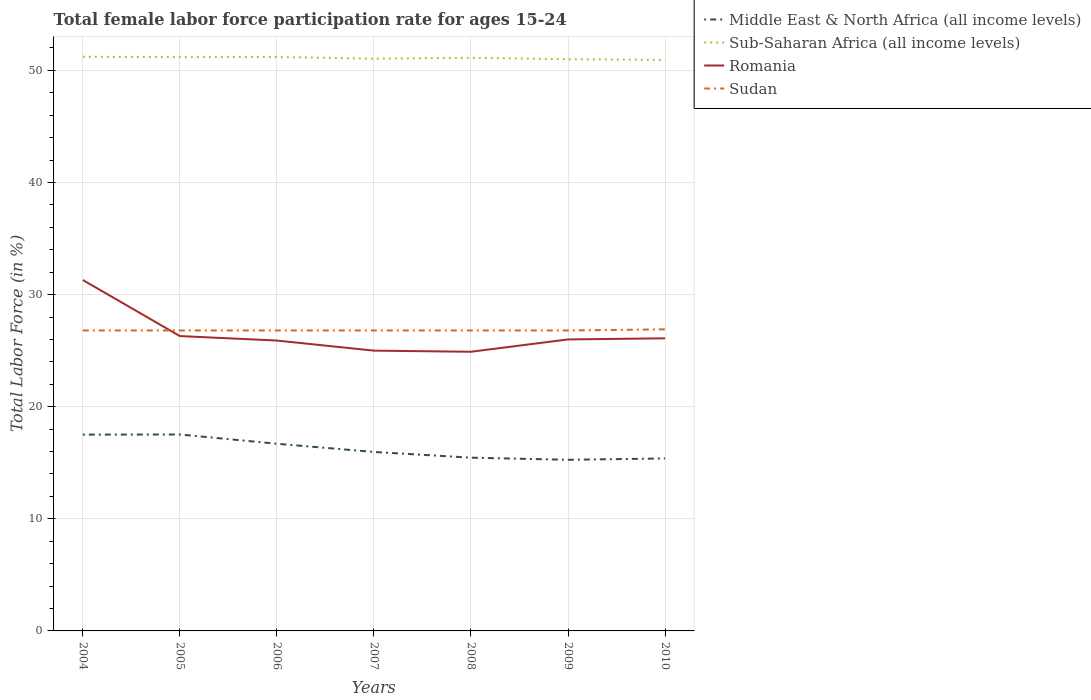Does the line corresponding to Sub-Saharan Africa (all income levels) intersect with the line corresponding to Middle East & North Africa (all income levels)?
Give a very brief answer. No. Is the number of lines equal to the number of legend labels?
Make the answer very short. Yes. Across all years, what is the maximum female labor force participation rate in Sub-Saharan Africa (all income levels)?
Give a very brief answer. 50.93. In which year was the female labor force participation rate in Sudan maximum?
Your response must be concise. 2004. What is the total female labor force participation rate in Romania in the graph?
Your answer should be very brief. 6.4. What is the difference between the highest and the second highest female labor force participation rate in Middle East & North Africa (all income levels)?
Your answer should be very brief. 2.26. How many lines are there?
Provide a short and direct response. 4. How many years are there in the graph?
Offer a terse response. 7. Does the graph contain grids?
Offer a terse response. Yes. Where does the legend appear in the graph?
Give a very brief answer. Top right. How many legend labels are there?
Provide a short and direct response. 4. What is the title of the graph?
Provide a short and direct response. Total female labor force participation rate for ages 15-24. Does "Chad" appear as one of the legend labels in the graph?
Make the answer very short. No. What is the Total Labor Force (in %) in Middle East & North Africa (all income levels) in 2004?
Your answer should be compact. 17.51. What is the Total Labor Force (in %) in Sub-Saharan Africa (all income levels) in 2004?
Your response must be concise. 51.22. What is the Total Labor Force (in %) of Romania in 2004?
Ensure brevity in your answer.  31.3. What is the Total Labor Force (in %) in Sudan in 2004?
Ensure brevity in your answer.  26.8. What is the Total Labor Force (in %) in Middle East & North Africa (all income levels) in 2005?
Provide a succinct answer. 17.52. What is the Total Labor Force (in %) in Sub-Saharan Africa (all income levels) in 2005?
Offer a very short reply. 51.18. What is the Total Labor Force (in %) in Romania in 2005?
Your answer should be compact. 26.3. What is the Total Labor Force (in %) in Sudan in 2005?
Your response must be concise. 26.8. What is the Total Labor Force (in %) in Middle East & North Africa (all income levels) in 2006?
Provide a succinct answer. 16.69. What is the Total Labor Force (in %) in Sub-Saharan Africa (all income levels) in 2006?
Provide a short and direct response. 51.19. What is the Total Labor Force (in %) in Romania in 2006?
Provide a succinct answer. 25.9. What is the Total Labor Force (in %) in Sudan in 2006?
Offer a terse response. 26.8. What is the Total Labor Force (in %) in Middle East & North Africa (all income levels) in 2007?
Your response must be concise. 15.96. What is the Total Labor Force (in %) of Sub-Saharan Africa (all income levels) in 2007?
Your answer should be compact. 51.04. What is the Total Labor Force (in %) in Romania in 2007?
Ensure brevity in your answer.  25. What is the Total Labor Force (in %) of Sudan in 2007?
Ensure brevity in your answer.  26.8. What is the Total Labor Force (in %) in Middle East & North Africa (all income levels) in 2008?
Your answer should be very brief. 15.45. What is the Total Labor Force (in %) in Sub-Saharan Africa (all income levels) in 2008?
Make the answer very short. 51.12. What is the Total Labor Force (in %) in Romania in 2008?
Provide a short and direct response. 24.9. What is the Total Labor Force (in %) of Sudan in 2008?
Your response must be concise. 26.8. What is the Total Labor Force (in %) of Middle East & North Africa (all income levels) in 2009?
Your response must be concise. 15.26. What is the Total Labor Force (in %) of Sub-Saharan Africa (all income levels) in 2009?
Give a very brief answer. 50.99. What is the Total Labor Force (in %) of Sudan in 2009?
Your response must be concise. 26.8. What is the Total Labor Force (in %) in Middle East & North Africa (all income levels) in 2010?
Give a very brief answer. 15.38. What is the Total Labor Force (in %) in Sub-Saharan Africa (all income levels) in 2010?
Provide a short and direct response. 50.93. What is the Total Labor Force (in %) in Romania in 2010?
Provide a short and direct response. 26.1. What is the Total Labor Force (in %) in Sudan in 2010?
Your answer should be compact. 26.9. Across all years, what is the maximum Total Labor Force (in %) in Middle East & North Africa (all income levels)?
Give a very brief answer. 17.52. Across all years, what is the maximum Total Labor Force (in %) of Sub-Saharan Africa (all income levels)?
Your response must be concise. 51.22. Across all years, what is the maximum Total Labor Force (in %) in Romania?
Your answer should be compact. 31.3. Across all years, what is the maximum Total Labor Force (in %) in Sudan?
Ensure brevity in your answer.  26.9. Across all years, what is the minimum Total Labor Force (in %) of Middle East & North Africa (all income levels)?
Give a very brief answer. 15.26. Across all years, what is the minimum Total Labor Force (in %) of Sub-Saharan Africa (all income levels)?
Keep it short and to the point. 50.93. Across all years, what is the minimum Total Labor Force (in %) in Romania?
Provide a succinct answer. 24.9. Across all years, what is the minimum Total Labor Force (in %) in Sudan?
Your response must be concise. 26.8. What is the total Total Labor Force (in %) of Middle East & North Africa (all income levels) in the graph?
Provide a succinct answer. 113.79. What is the total Total Labor Force (in %) in Sub-Saharan Africa (all income levels) in the graph?
Provide a succinct answer. 357.68. What is the total Total Labor Force (in %) of Romania in the graph?
Ensure brevity in your answer.  185.5. What is the total Total Labor Force (in %) in Sudan in the graph?
Ensure brevity in your answer.  187.7. What is the difference between the Total Labor Force (in %) of Middle East & North Africa (all income levels) in 2004 and that in 2005?
Your answer should be compact. -0.01. What is the difference between the Total Labor Force (in %) in Sub-Saharan Africa (all income levels) in 2004 and that in 2005?
Ensure brevity in your answer.  0.04. What is the difference between the Total Labor Force (in %) of Middle East & North Africa (all income levels) in 2004 and that in 2006?
Keep it short and to the point. 0.81. What is the difference between the Total Labor Force (in %) of Sub-Saharan Africa (all income levels) in 2004 and that in 2006?
Your answer should be compact. 0.02. What is the difference between the Total Labor Force (in %) of Sudan in 2004 and that in 2006?
Offer a very short reply. 0. What is the difference between the Total Labor Force (in %) of Middle East & North Africa (all income levels) in 2004 and that in 2007?
Offer a very short reply. 1.55. What is the difference between the Total Labor Force (in %) in Sub-Saharan Africa (all income levels) in 2004 and that in 2007?
Make the answer very short. 0.17. What is the difference between the Total Labor Force (in %) in Romania in 2004 and that in 2007?
Provide a succinct answer. 6.3. What is the difference between the Total Labor Force (in %) in Sudan in 2004 and that in 2007?
Give a very brief answer. 0. What is the difference between the Total Labor Force (in %) of Middle East & North Africa (all income levels) in 2004 and that in 2008?
Provide a short and direct response. 2.06. What is the difference between the Total Labor Force (in %) in Sub-Saharan Africa (all income levels) in 2004 and that in 2008?
Your answer should be compact. 0.1. What is the difference between the Total Labor Force (in %) of Sudan in 2004 and that in 2008?
Provide a succinct answer. 0. What is the difference between the Total Labor Force (in %) of Middle East & North Africa (all income levels) in 2004 and that in 2009?
Make the answer very short. 2.25. What is the difference between the Total Labor Force (in %) of Sub-Saharan Africa (all income levels) in 2004 and that in 2009?
Provide a succinct answer. 0.22. What is the difference between the Total Labor Force (in %) of Middle East & North Africa (all income levels) in 2004 and that in 2010?
Your answer should be compact. 2.13. What is the difference between the Total Labor Force (in %) in Sub-Saharan Africa (all income levels) in 2004 and that in 2010?
Keep it short and to the point. 0.28. What is the difference between the Total Labor Force (in %) in Romania in 2004 and that in 2010?
Give a very brief answer. 5.2. What is the difference between the Total Labor Force (in %) in Sudan in 2004 and that in 2010?
Offer a terse response. -0.1. What is the difference between the Total Labor Force (in %) of Middle East & North Africa (all income levels) in 2005 and that in 2006?
Your answer should be compact. 0.83. What is the difference between the Total Labor Force (in %) in Sub-Saharan Africa (all income levels) in 2005 and that in 2006?
Give a very brief answer. -0.01. What is the difference between the Total Labor Force (in %) of Sudan in 2005 and that in 2006?
Make the answer very short. 0. What is the difference between the Total Labor Force (in %) of Middle East & North Africa (all income levels) in 2005 and that in 2007?
Keep it short and to the point. 1.56. What is the difference between the Total Labor Force (in %) in Sub-Saharan Africa (all income levels) in 2005 and that in 2007?
Make the answer very short. 0.14. What is the difference between the Total Labor Force (in %) of Middle East & North Africa (all income levels) in 2005 and that in 2008?
Provide a succinct answer. 2.07. What is the difference between the Total Labor Force (in %) of Middle East & North Africa (all income levels) in 2005 and that in 2009?
Provide a short and direct response. 2.26. What is the difference between the Total Labor Force (in %) of Sub-Saharan Africa (all income levels) in 2005 and that in 2009?
Offer a terse response. 0.19. What is the difference between the Total Labor Force (in %) of Romania in 2005 and that in 2009?
Your answer should be very brief. 0.3. What is the difference between the Total Labor Force (in %) of Sudan in 2005 and that in 2009?
Make the answer very short. 0. What is the difference between the Total Labor Force (in %) of Middle East & North Africa (all income levels) in 2005 and that in 2010?
Your answer should be compact. 2.14. What is the difference between the Total Labor Force (in %) in Sub-Saharan Africa (all income levels) in 2005 and that in 2010?
Provide a succinct answer. 0.25. What is the difference between the Total Labor Force (in %) of Middle East & North Africa (all income levels) in 2006 and that in 2007?
Make the answer very short. 0.73. What is the difference between the Total Labor Force (in %) of Sub-Saharan Africa (all income levels) in 2006 and that in 2007?
Offer a terse response. 0.15. What is the difference between the Total Labor Force (in %) of Romania in 2006 and that in 2007?
Provide a succinct answer. 0.9. What is the difference between the Total Labor Force (in %) of Middle East & North Africa (all income levels) in 2006 and that in 2008?
Your response must be concise. 1.24. What is the difference between the Total Labor Force (in %) of Sub-Saharan Africa (all income levels) in 2006 and that in 2008?
Your answer should be very brief. 0.07. What is the difference between the Total Labor Force (in %) of Romania in 2006 and that in 2008?
Your response must be concise. 1. What is the difference between the Total Labor Force (in %) of Sudan in 2006 and that in 2008?
Give a very brief answer. 0. What is the difference between the Total Labor Force (in %) of Middle East & North Africa (all income levels) in 2006 and that in 2009?
Ensure brevity in your answer.  1.43. What is the difference between the Total Labor Force (in %) in Sub-Saharan Africa (all income levels) in 2006 and that in 2009?
Provide a succinct answer. 0.2. What is the difference between the Total Labor Force (in %) of Middle East & North Africa (all income levels) in 2006 and that in 2010?
Give a very brief answer. 1.31. What is the difference between the Total Labor Force (in %) of Sub-Saharan Africa (all income levels) in 2006 and that in 2010?
Keep it short and to the point. 0.26. What is the difference between the Total Labor Force (in %) in Romania in 2006 and that in 2010?
Your answer should be compact. -0.2. What is the difference between the Total Labor Force (in %) in Middle East & North Africa (all income levels) in 2007 and that in 2008?
Provide a short and direct response. 0.51. What is the difference between the Total Labor Force (in %) of Sub-Saharan Africa (all income levels) in 2007 and that in 2008?
Your answer should be compact. -0.08. What is the difference between the Total Labor Force (in %) in Romania in 2007 and that in 2008?
Your answer should be very brief. 0.1. What is the difference between the Total Labor Force (in %) in Sudan in 2007 and that in 2008?
Provide a short and direct response. 0. What is the difference between the Total Labor Force (in %) in Middle East & North Africa (all income levels) in 2007 and that in 2009?
Your answer should be very brief. 0.7. What is the difference between the Total Labor Force (in %) in Sub-Saharan Africa (all income levels) in 2007 and that in 2009?
Provide a short and direct response. 0.05. What is the difference between the Total Labor Force (in %) in Romania in 2007 and that in 2009?
Your answer should be very brief. -1. What is the difference between the Total Labor Force (in %) of Sudan in 2007 and that in 2009?
Your answer should be very brief. 0. What is the difference between the Total Labor Force (in %) of Middle East & North Africa (all income levels) in 2007 and that in 2010?
Give a very brief answer. 0.58. What is the difference between the Total Labor Force (in %) of Sub-Saharan Africa (all income levels) in 2007 and that in 2010?
Make the answer very short. 0.11. What is the difference between the Total Labor Force (in %) in Romania in 2007 and that in 2010?
Offer a terse response. -1.1. What is the difference between the Total Labor Force (in %) of Middle East & North Africa (all income levels) in 2008 and that in 2009?
Keep it short and to the point. 0.19. What is the difference between the Total Labor Force (in %) in Sub-Saharan Africa (all income levels) in 2008 and that in 2009?
Provide a succinct answer. 0.13. What is the difference between the Total Labor Force (in %) in Sudan in 2008 and that in 2009?
Your answer should be compact. 0. What is the difference between the Total Labor Force (in %) of Middle East & North Africa (all income levels) in 2008 and that in 2010?
Your response must be concise. 0.07. What is the difference between the Total Labor Force (in %) in Sub-Saharan Africa (all income levels) in 2008 and that in 2010?
Give a very brief answer. 0.19. What is the difference between the Total Labor Force (in %) of Sudan in 2008 and that in 2010?
Offer a terse response. -0.1. What is the difference between the Total Labor Force (in %) in Middle East & North Africa (all income levels) in 2009 and that in 2010?
Give a very brief answer. -0.12. What is the difference between the Total Labor Force (in %) in Sub-Saharan Africa (all income levels) in 2009 and that in 2010?
Your answer should be very brief. 0.06. What is the difference between the Total Labor Force (in %) of Middle East & North Africa (all income levels) in 2004 and the Total Labor Force (in %) of Sub-Saharan Africa (all income levels) in 2005?
Provide a short and direct response. -33.67. What is the difference between the Total Labor Force (in %) in Middle East & North Africa (all income levels) in 2004 and the Total Labor Force (in %) in Romania in 2005?
Keep it short and to the point. -8.79. What is the difference between the Total Labor Force (in %) in Middle East & North Africa (all income levels) in 2004 and the Total Labor Force (in %) in Sudan in 2005?
Your answer should be very brief. -9.29. What is the difference between the Total Labor Force (in %) of Sub-Saharan Africa (all income levels) in 2004 and the Total Labor Force (in %) of Romania in 2005?
Your answer should be compact. 24.92. What is the difference between the Total Labor Force (in %) of Sub-Saharan Africa (all income levels) in 2004 and the Total Labor Force (in %) of Sudan in 2005?
Offer a terse response. 24.42. What is the difference between the Total Labor Force (in %) in Romania in 2004 and the Total Labor Force (in %) in Sudan in 2005?
Keep it short and to the point. 4.5. What is the difference between the Total Labor Force (in %) in Middle East & North Africa (all income levels) in 2004 and the Total Labor Force (in %) in Sub-Saharan Africa (all income levels) in 2006?
Keep it short and to the point. -33.68. What is the difference between the Total Labor Force (in %) in Middle East & North Africa (all income levels) in 2004 and the Total Labor Force (in %) in Romania in 2006?
Your answer should be compact. -8.39. What is the difference between the Total Labor Force (in %) of Middle East & North Africa (all income levels) in 2004 and the Total Labor Force (in %) of Sudan in 2006?
Keep it short and to the point. -9.29. What is the difference between the Total Labor Force (in %) in Sub-Saharan Africa (all income levels) in 2004 and the Total Labor Force (in %) in Romania in 2006?
Your answer should be compact. 25.32. What is the difference between the Total Labor Force (in %) of Sub-Saharan Africa (all income levels) in 2004 and the Total Labor Force (in %) of Sudan in 2006?
Your response must be concise. 24.42. What is the difference between the Total Labor Force (in %) in Middle East & North Africa (all income levels) in 2004 and the Total Labor Force (in %) in Sub-Saharan Africa (all income levels) in 2007?
Your response must be concise. -33.53. What is the difference between the Total Labor Force (in %) of Middle East & North Africa (all income levels) in 2004 and the Total Labor Force (in %) of Romania in 2007?
Offer a very short reply. -7.49. What is the difference between the Total Labor Force (in %) of Middle East & North Africa (all income levels) in 2004 and the Total Labor Force (in %) of Sudan in 2007?
Provide a succinct answer. -9.29. What is the difference between the Total Labor Force (in %) in Sub-Saharan Africa (all income levels) in 2004 and the Total Labor Force (in %) in Romania in 2007?
Offer a terse response. 26.22. What is the difference between the Total Labor Force (in %) in Sub-Saharan Africa (all income levels) in 2004 and the Total Labor Force (in %) in Sudan in 2007?
Make the answer very short. 24.42. What is the difference between the Total Labor Force (in %) in Romania in 2004 and the Total Labor Force (in %) in Sudan in 2007?
Offer a very short reply. 4.5. What is the difference between the Total Labor Force (in %) in Middle East & North Africa (all income levels) in 2004 and the Total Labor Force (in %) in Sub-Saharan Africa (all income levels) in 2008?
Provide a short and direct response. -33.61. What is the difference between the Total Labor Force (in %) of Middle East & North Africa (all income levels) in 2004 and the Total Labor Force (in %) of Romania in 2008?
Your answer should be compact. -7.39. What is the difference between the Total Labor Force (in %) of Middle East & North Africa (all income levels) in 2004 and the Total Labor Force (in %) of Sudan in 2008?
Give a very brief answer. -9.29. What is the difference between the Total Labor Force (in %) of Sub-Saharan Africa (all income levels) in 2004 and the Total Labor Force (in %) of Romania in 2008?
Provide a short and direct response. 26.32. What is the difference between the Total Labor Force (in %) of Sub-Saharan Africa (all income levels) in 2004 and the Total Labor Force (in %) of Sudan in 2008?
Your answer should be compact. 24.42. What is the difference between the Total Labor Force (in %) of Romania in 2004 and the Total Labor Force (in %) of Sudan in 2008?
Offer a terse response. 4.5. What is the difference between the Total Labor Force (in %) of Middle East & North Africa (all income levels) in 2004 and the Total Labor Force (in %) of Sub-Saharan Africa (all income levels) in 2009?
Ensure brevity in your answer.  -33.48. What is the difference between the Total Labor Force (in %) of Middle East & North Africa (all income levels) in 2004 and the Total Labor Force (in %) of Romania in 2009?
Provide a short and direct response. -8.49. What is the difference between the Total Labor Force (in %) of Middle East & North Africa (all income levels) in 2004 and the Total Labor Force (in %) of Sudan in 2009?
Your answer should be very brief. -9.29. What is the difference between the Total Labor Force (in %) of Sub-Saharan Africa (all income levels) in 2004 and the Total Labor Force (in %) of Romania in 2009?
Ensure brevity in your answer.  25.22. What is the difference between the Total Labor Force (in %) of Sub-Saharan Africa (all income levels) in 2004 and the Total Labor Force (in %) of Sudan in 2009?
Keep it short and to the point. 24.42. What is the difference between the Total Labor Force (in %) of Romania in 2004 and the Total Labor Force (in %) of Sudan in 2009?
Provide a short and direct response. 4.5. What is the difference between the Total Labor Force (in %) of Middle East & North Africa (all income levels) in 2004 and the Total Labor Force (in %) of Sub-Saharan Africa (all income levels) in 2010?
Your response must be concise. -33.42. What is the difference between the Total Labor Force (in %) in Middle East & North Africa (all income levels) in 2004 and the Total Labor Force (in %) in Romania in 2010?
Your answer should be compact. -8.59. What is the difference between the Total Labor Force (in %) of Middle East & North Africa (all income levels) in 2004 and the Total Labor Force (in %) of Sudan in 2010?
Make the answer very short. -9.39. What is the difference between the Total Labor Force (in %) of Sub-Saharan Africa (all income levels) in 2004 and the Total Labor Force (in %) of Romania in 2010?
Your response must be concise. 25.12. What is the difference between the Total Labor Force (in %) of Sub-Saharan Africa (all income levels) in 2004 and the Total Labor Force (in %) of Sudan in 2010?
Give a very brief answer. 24.32. What is the difference between the Total Labor Force (in %) of Middle East & North Africa (all income levels) in 2005 and the Total Labor Force (in %) of Sub-Saharan Africa (all income levels) in 2006?
Keep it short and to the point. -33.67. What is the difference between the Total Labor Force (in %) of Middle East & North Africa (all income levels) in 2005 and the Total Labor Force (in %) of Romania in 2006?
Offer a very short reply. -8.38. What is the difference between the Total Labor Force (in %) of Middle East & North Africa (all income levels) in 2005 and the Total Labor Force (in %) of Sudan in 2006?
Your response must be concise. -9.28. What is the difference between the Total Labor Force (in %) in Sub-Saharan Africa (all income levels) in 2005 and the Total Labor Force (in %) in Romania in 2006?
Provide a short and direct response. 25.28. What is the difference between the Total Labor Force (in %) of Sub-Saharan Africa (all income levels) in 2005 and the Total Labor Force (in %) of Sudan in 2006?
Your answer should be compact. 24.38. What is the difference between the Total Labor Force (in %) in Middle East & North Africa (all income levels) in 2005 and the Total Labor Force (in %) in Sub-Saharan Africa (all income levels) in 2007?
Keep it short and to the point. -33.52. What is the difference between the Total Labor Force (in %) in Middle East & North Africa (all income levels) in 2005 and the Total Labor Force (in %) in Romania in 2007?
Ensure brevity in your answer.  -7.48. What is the difference between the Total Labor Force (in %) of Middle East & North Africa (all income levels) in 2005 and the Total Labor Force (in %) of Sudan in 2007?
Keep it short and to the point. -9.28. What is the difference between the Total Labor Force (in %) of Sub-Saharan Africa (all income levels) in 2005 and the Total Labor Force (in %) of Romania in 2007?
Keep it short and to the point. 26.18. What is the difference between the Total Labor Force (in %) in Sub-Saharan Africa (all income levels) in 2005 and the Total Labor Force (in %) in Sudan in 2007?
Provide a succinct answer. 24.38. What is the difference between the Total Labor Force (in %) of Romania in 2005 and the Total Labor Force (in %) of Sudan in 2007?
Ensure brevity in your answer.  -0.5. What is the difference between the Total Labor Force (in %) in Middle East & North Africa (all income levels) in 2005 and the Total Labor Force (in %) in Sub-Saharan Africa (all income levels) in 2008?
Offer a very short reply. -33.6. What is the difference between the Total Labor Force (in %) in Middle East & North Africa (all income levels) in 2005 and the Total Labor Force (in %) in Romania in 2008?
Your answer should be compact. -7.38. What is the difference between the Total Labor Force (in %) in Middle East & North Africa (all income levels) in 2005 and the Total Labor Force (in %) in Sudan in 2008?
Offer a terse response. -9.28. What is the difference between the Total Labor Force (in %) of Sub-Saharan Africa (all income levels) in 2005 and the Total Labor Force (in %) of Romania in 2008?
Your answer should be compact. 26.28. What is the difference between the Total Labor Force (in %) of Sub-Saharan Africa (all income levels) in 2005 and the Total Labor Force (in %) of Sudan in 2008?
Keep it short and to the point. 24.38. What is the difference between the Total Labor Force (in %) in Middle East & North Africa (all income levels) in 2005 and the Total Labor Force (in %) in Sub-Saharan Africa (all income levels) in 2009?
Offer a terse response. -33.47. What is the difference between the Total Labor Force (in %) of Middle East & North Africa (all income levels) in 2005 and the Total Labor Force (in %) of Romania in 2009?
Your answer should be compact. -8.48. What is the difference between the Total Labor Force (in %) in Middle East & North Africa (all income levels) in 2005 and the Total Labor Force (in %) in Sudan in 2009?
Give a very brief answer. -9.28. What is the difference between the Total Labor Force (in %) of Sub-Saharan Africa (all income levels) in 2005 and the Total Labor Force (in %) of Romania in 2009?
Your answer should be very brief. 25.18. What is the difference between the Total Labor Force (in %) of Sub-Saharan Africa (all income levels) in 2005 and the Total Labor Force (in %) of Sudan in 2009?
Your answer should be very brief. 24.38. What is the difference between the Total Labor Force (in %) of Romania in 2005 and the Total Labor Force (in %) of Sudan in 2009?
Ensure brevity in your answer.  -0.5. What is the difference between the Total Labor Force (in %) of Middle East & North Africa (all income levels) in 2005 and the Total Labor Force (in %) of Sub-Saharan Africa (all income levels) in 2010?
Offer a very short reply. -33.41. What is the difference between the Total Labor Force (in %) of Middle East & North Africa (all income levels) in 2005 and the Total Labor Force (in %) of Romania in 2010?
Your answer should be very brief. -8.58. What is the difference between the Total Labor Force (in %) of Middle East & North Africa (all income levels) in 2005 and the Total Labor Force (in %) of Sudan in 2010?
Ensure brevity in your answer.  -9.38. What is the difference between the Total Labor Force (in %) in Sub-Saharan Africa (all income levels) in 2005 and the Total Labor Force (in %) in Romania in 2010?
Make the answer very short. 25.08. What is the difference between the Total Labor Force (in %) of Sub-Saharan Africa (all income levels) in 2005 and the Total Labor Force (in %) of Sudan in 2010?
Provide a succinct answer. 24.28. What is the difference between the Total Labor Force (in %) of Middle East & North Africa (all income levels) in 2006 and the Total Labor Force (in %) of Sub-Saharan Africa (all income levels) in 2007?
Give a very brief answer. -34.35. What is the difference between the Total Labor Force (in %) of Middle East & North Africa (all income levels) in 2006 and the Total Labor Force (in %) of Romania in 2007?
Keep it short and to the point. -8.3. What is the difference between the Total Labor Force (in %) of Middle East & North Africa (all income levels) in 2006 and the Total Labor Force (in %) of Sudan in 2007?
Keep it short and to the point. -10.11. What is the difference between the Total Labor Force (in %) in Sub-Saharan Africa (all income levels) in 2006 and the Total Labor Force (in %) in Romania in 2007?
Ensure brevity in your answer.  26.19. What is the difference between the Total Labor Force (in %) in Sub-Saharan Africa (all income levels) in 2006 and the Total Labor Force (in %) in Sudan in 2007?
Your answer should be very brief. 24.39. What is the difference between the Total Labor Force (in %) of Middle East & North Africa (all income levels) in 2006 and the Total Labor Force (in %) of Sub-Saharan Africa (all income levels) in 2008?
Your answer should be compact. -34.42. What is the difference between the Total Labor Force (in %) of Middle East & North Africa (all income levels) in 2006 and the Total Labor Force (in %) of Romania in 2008?
Your answer should be compact. -8.21. What is the difference between the Total Labor Force (in %) of Middle East & North Africa (all income levels) in 2006 and the Total Labor Force (in %) of Sudan in 2008?
Ensure brevity in your answer.  -10.11. What is the difference between the Total Labor Force (in %) of Sub-Saharan Africa (all income levels) in 2006 and the Total Labor Force (in %) of Romania in 2008?
Your response must be concise. 26.29. What is the difference between the Total Labor Force (in %) in Sub-Saharan Africa (all income levels) in 2006 and the Total Labor Force (in %) in Sudan in 2008?
Ensure brevity in your answer.  24.39. What is the difference between the Total Labor Force (in %) of Middle East & North Africa (all income levels) in 2006 and the Total Labor Force (in %) of Sub-Saharan Africa (all income levels) in 2009?
Your answer should be very brief. -34.3. What is the difference between the Total Labor Force (in %) of Middle East & North Africa (all income levels) in 2006 and the Total Labor Force (in %) of Romania in 2009?
Provide a succinct answer. -9.3. What is the difference between the Total Labor Force (in %) in Middle East & North Africa (all income levels) in 2006 and the Total Labor Force (in %) in Sudan in 2009?
Give a very brief answer. -10.11. What is the difference between the Total Labor Force (in %) of Sub-Saharan Africa (all income levels) in 2006 and the Total Labor Force (in %) of Romania in 2009?
Provide a succinct answer. 25.19. What is the difference between the Total Labor Force (in %) in Sub-Saharan Africa (all income levels) in 2006 and the Total Labor Force (in %) in Sudan in 2009?
Offer a very short reply. 24.39. What is the difference between the Total Labor Force (in %) of Romania in 2006 and the Total Labor Force (in %) of Sudan in 2009?
Your response must be concise. -0.9. What is the difference between the Total Labor Force (in %) of Middle East & North Africa (all income levels) in 2006 and the Total Labor Force (in %) of Sub-Saharan Africa (all income levels) in 2010?
Offer a very short reply. -34.24. What is the difference between the Total Labor Force (in %) in Middle East & North Africa (all income levels) in 2006 and the Total Labor Force (in %) in Romania in 2010?
Offer a terse response. -9.4. What is the difference between the Total Labor Force (in %) in Middle East & North Africa (all income levels) in 2006 and the Total Labor Force (in %) in Sudan in 2010?
Your answer should be compact. -10.21. What is the difference between the Total Labor Force (in %) in Sub-Saharan Africa (all income levels) in 2006 and the Total Labor Force (in %) in Romania in 2010?
Your response must be concise. 25.09. What is the difference between the Total Labor Force (in %) in Sub-Saharan Africa (all income levels) in 2006 and the Total Labor Force (in %) in Sudan in 2010?
Offer a terse response. 24.29. What is the difference between the Total Labor Force (in %) of Romania in 2006 and the Total Labor Force (in %) of Sudan in 2010?
Give a very brief answer. -1. What is the difference between the Total Labor Force (in %) of Middle East & North Africa (all income levels) in 2007 and the Total Labor Force (in %) of Sub-Saharan Africa (all income levels) in 2008?
Provide a succinct answer. -35.16. What is the difference between the Total Labor Force (in %) of Middle East & North Africa (all income levels) in 2007 and the Total Labor Force (in %) of Romania in 2008?
Your response must be concise. -8.94. What is the difference between the Total Labor Force (in %) of Middle East & North Africa (all income levels) in 2007 and the Total Labor Force (in %) of Sudan in 2008?
Ensure brevity in your answer.  -10.84. What is the difference between the Total Labor Force (in %) of Sub-Saharan Africa (all income levels) in 2007 and the Total Labor Force (in %) of Romania in 2008?
Provide a short and direct response. 26.14. What is the difference between the Total Labor Force (in %) of Sub-Saharan Africa (all income levels) in 2007 and the Total Labor Force (in %) of Sudan in 2008?
Keep it short and to the point. 24.24. What is the difference between the Total Labor Force (in %) in Romania in 2007 and the Total Labor Force (in %) in Sudan in 2008?
Your response must be concise. -1.8. What is the difference between the Total Labor Force (in %) of Middle East & North Africa (all income levels) in 2007 and the Total Labor Force (in %) of Sub-Saharan Africa (all income levels) in 2009?
Your response must be concise. -35.03. What is the difference between the Total Labor Force (in %) in Middle East & North Africa (all income levels) in 2007 and the Total Labor Force (in %) in Romania in 2009?
Make the answer very short. -10.04. What is the difference between the Total Labor Force (in %) of Middle East & North Africa (all income levels) in 2007 and the Total Labor Force (in %) of Sudan in 2009?
Your response must be concise. -10.84. What is the difference between the Total Labor Force (in %) in Sub-Saharan Africa (all income levels) in 2007 and the Total Labor Force (in %) in Romania in 2009?
Provide a short and direct response. 25.04. What is the difference between the Total Labor Force (in %) of Sub-Saharan Africa (all income levels) in 2007 and the Total Labor Force (in %) of Sudan in 2009?
Your response must be concise. 24.24. What is the difference between the Total Labor Force (in %) in Romania in 2007 and the Total Labor Force (in %) in Sudan in 2009?
Give a very brief answer. -1.8. What is the difference between the Total Labor Force (in %) of Middle East & North Africa (all income levels) in 2007 and the Total Labor Force (in %) of Sub-Saharan Africa (all income levels) in 2010?
Your answer should be very brief. -34.97. What is the difference between the Total Labor Force (in %) of Middle East & North Africa (all income levels) in 2007 and the Total Labor Force (in %) of Romania in 2010?
Provide a succinct answer. -10.14. What is the difference between the Total Labor Force (in %) of Middle East & North Africa (all income levels) in 2007 and the Total Labor Force (in %) of Sudan in 2010?
Provide a succinct answer. -10.94. What is the difference between the Total Labor Force (in %) in Sub-Saharan Africa (all income levels) in 2007 and the Total Labor Force (in %) in Romania in 2010?
Offer a very short reply. 24.94. What is the difference between the Total Labor Force (in %) of Sub-Saharan Africa (all income levels) in 2007 and the Total Labor Force (in %) of Sudan in 2010?
Make the answer very short. 24.14. What is the difference between the Total Labor Force (in %) of Middle East & North Africa (all income levels) in 2008 and the Total Labor Force (in %) of Sub-Saharan Africa (all income levels) in 2009?
Make the answer very short. -35.54. What is the difference between the Total Labor Force (in %) of Middle East & North Africa (all income levels) in 2008 and the Total Labor Force (in %) of Romania in 2009?
Your answer should be very brief. -10.55. What is the difference between the Total Labor Force (in %) in Middle East & North Africa (all income levels) in 2008 and the Total Labor Force (in %) in Sudan in 2009?
Ensure brevity in your answer.  -11.35. What is the difference between the Total Labor Force (in %) in Sub-Saharan Africa (all income levels) in 2008 and the Total Labor Force (in %) in Romania in 2009?
Your answer should be compact. 25.12. What is the difference between the Total Labor Force (in %) in Sub-Saharan Africa (all income levels) in 2008 and the Total Labor Force (in %) in Sudan in 2009?
Provide a succinct answer. 24.32. What is the difference between the Total Labor Force (in %) of Middle East & North Africa (all income levels) in 2008 and the Total Labor Force (in %) of Sub-Saharan Africa (all income levels) in 2010?
Give a very brief answer. -35.48. What is the difference between the Total Labor Force (in %) in Middle East & North Africa (all income levels) in 2008 and the Total Labor Force (in %) in Romania in 2010?
Provide a short and direct response. -10.65. What is the difference between the Total Labor Force (in %) of Middle East & North Africa (all income levels) in 2008 and the Total Labor Force (in %) of Sudan in 2010?
Keep it short and to the point. -11.45. What is the difference between the Total Labor Force (in %) of Sub-Saharan Africa (all income levels) in 2008 and the Total Labor Force (in %) of Romania in 2010?
Give a very brief answer. 25.02. What is the difference between the Total Labor Force (in %) of Sub-Saharan Africa (all income levels) in 2008 and the Total Labor Force (in %) of Sudan in 2010?
Ensure brevity in your answer.  24.22. What is the difference between the Total Labor Force (in %) of Romania in 2008 and the Total Labor Force (in %) of Sudan in 2010?
Make the answer very short. -2. What is the difference between the Total Labor Force (in %) in Middle East & North Africa (all income levels) in 2009 and the Total Labor Force (in %) in Sub-Saharan Africa (all income levels) in 2010?
Give a very brief answer. -35.67. What is the difference between the Total Labor Force (in %) in Middle East & North Africa (all income levels) in 2009 and the Total Labor Force (in %) in Romania in 2010?
Your answer should be very brief. -10.84. What is the difference between the Total Labor Force (in %) in Middle East & North Africa (all income levels) in 2009 and the Total Labor Force (in %) in Sudan in 2010?
Keep it short and to the point. -11.64. What is the difference between the Total Labor Force (in %) in Sub-Saharan Africa (all income levels) in 2009 and the Total Labor Force (in %) in Romania in 2010?
Offer a very short reply. 24.89. What is the difference between the Total Labor Force (in %) of Sub-Saharan Africa (all income levels) in 2009 and the Total Labor Force (in %) of Sudan in 2010?
Provide a short and direct response. 24.09. What is the difference between the Total Labor Force (in %) of Romania in 2009 and the Total Labor Force (in %) of Sudan in 2010?
Provide a succinct answer. -0.9. What is the average Total Labor Force (in %) in Middle East & North Africa (all income levels) per year?
Offer a very short reply. 16.26. What is the average Total Labor Force (in %) of Sub-Saharan Africa (all income levels) per year?
Ensure brevity in your answer.  51.1. What is the average Total Labor Force (in %) of Romania per year?
Make the answer very short. 26.5. What is the average Total Labor Force (in %) in Sudan per year?
Your answer should be compact. 26.81. In the year 2004, what is the difference between the Total Labor Force (in %) in Middle East & North Africa (all income levels) and Total Labor Force (in %) in Sub-Saharan Africa (all income levels)?
Offer a terse response. -33.71. In the year 2004, what is the difference between the Total Labor Force (in %) of Middle East & North Africa (all income levels) and Total Labor Force (in %) of Romania?
Offer a very short reply. -13.79. In the year 2004, what is the difference between the Total Labor Force (in %) of Middle East & North Africa (all income levels) and Total Labor Force (in %) of Sudan?
Give a very brief answer. -9.29. In the year 2004, what is the difference between the Total Labor Force (in %) of Sub-Saharan Africa (all income levels) and Total Labor Force (in %) of Romania?
Your answer should be very brief. 19.92. In the year 2004, what is the difference between the Total Labor Force (in %) of Sub-Saharan Africa (all income levels) and Total Labor Force (in %) of Sudan?
Keep it short and to the point. 24.42. In the year 2004, what is the difference between the Total Labor Force (in %) of Romania and Total Labor Force (in %) of Sudan?
Your response must be concise. 4.5. In the year 2005, what is the difference between the Total Labor Force (in %) of Middle East & North Africa (all income levels) and Total Labor Force (in %) of Sub-Saharan Africa (all income levels)?
Ensure brevity in your answer.  -33.66. In the year 2005, what is the difference between the Total Labor Force (in %) in Middle East & North Africa (all income levels) and Total Labor Force (in %) in Romania?
Make the answer very short. -8.78. In the year 2005, what is the difference between the Total Labor Force (in %) of Middle East & North Africa (all income levels) and Total Labor Force (in %) of Sudan?
Your answer should be compact. -9.28. In the year 2005, what is the difference between the Total Labor Force (in %) of Sub-Saharan Africa (all income levels) and Total Labor Force (in %) of Romania?
Ensure brevity in your answer.  24.88. In the year 2005, what is the difference between the Total Labor Force (in %) in Sub-Saharan Africa (all income levels) and Total Labor Force (in %) in Sudan?
Your response must be concise. 24.38. In the year 2006, what is the difference between the Total Labor Force (in %) of Middle East & North Africa (all income levels) and Total Labor Force (in %) of Sub-Saharan Africa (all income levels)?
Offer a terse response. -34.5. In the year 2006, what is the difference between the Total Labor Force (in %) of Middle East & North Africa (all income levels) and Total Labor Force (in %) of Romania?
Provide a short and direct response. -9.21. In the year 2006, what is the difference between the Total Labor Force (in %) of Middle East & North Africa (all income levels) and Total Labor Force (in %) of Sudan?
Keep it short and to the point. -10.11. In the year 2006, what is the difference between the Total Labor Force (in %) of Sub-Saharan Africa (all income levels) and Total Labor Force (in %) of Romania?
Provide a succinct answer. 25.29. In the year 2006, what is the difference between the Total Labor Force (in %) of Sub-Saharan Africa (all income levels) and Total Labor Force (in %) of Sudan?
Your answer should be compact. 24.39. In the year 2006, what is the difference between the Total Labor Force (in %) in Romania and Total Labor Force (in %) in Sudan?
Make the answer very short. -0.9. In the year 2007, what is the difference between the Total Labor Force (in %) in Middle East & North Africa (all income levels) and Total Labor Force (in %) in Sub-Saharan Africa (all income levels)?
Offer a very short reply. -35.08. In the year 2007, what is the difference between the Total Labor Force (in %) of Middle East & North Africa (all income levels) and Total Labor Force (in %) of Romania?
Provide a short and direct response. -9.04. In the year 2007, what is the difference between the Total Labor Force (in %) in Middle East & North Africa (all income levels) and Total Labor Force (in %) in Sudan?
Keep it short and to the point. -10.84. In the year 2007, what is the difference between the Total Labor Force (in %) in Sub-Saharan Africa (all income levels) and Total Labor Force (in %) in Romania?
Your answer should be very brief. 26.04. In the year 2007, what is the difference between the Total Labor Force (in %) in Sub-Saharan Africa (all income levels) and Total Labor Force (in %) in Sudan?
Your answer should be compact. 24.24. In the year 2007, what is the difference between the Total Labor Force (in %) of Romania and Total Labor Force (in %) of Sudan?
Your answer should be very brief. -1.8. In the year 2008, what is the difference between the Total Labor Force (in %) of Middle East & North Africa (all income levels) and Total Labor Force (in %) of Sub-Saharan Africa (all income levels)?
Ensure brevity in your answer.  -35.67. In the year 2008, what is the difference between the Total Labor Force (in %) in Middle East & North Africa (all income levels) and Total Labor Force (in %) in Romania?
Offer a very short reply. -9.45. In the year 2008, what is the difference between the Total Labor Force (in %) of Middle East & North Africa (all income levels) and Total Labor Force (in %) of Sudan?
Ensure brevity in your answer.  -11.35. In the year 2008, what is the difference between the Total Labor Force (in %) in Sub-Saharan Africa (all income levels) and Total Labor Force (in %) in Romania?
Provide a succinct answer. 26.22. In the year 2008, what is the difference between the Total Labor Force (in %) in Sub-Saharan Africa (all income levels) and Total Labor Force (in %) in Sudan?
Offer a terse response. 24.32. In the year 2009, what is the difference between the Total Labor Force (in %) in Middle East & North Africa (all income levels) and Total Labor Force (in %) in Sub-Saharan Africa (all income levels)?
Keep it short and to the point. -35.73. In the year 2009, what is the difference between the Total Labor Force (in %) in Middle East & North Africa (all income levels) and Total Labor Force (in %) in Romania?
Your response must be concise. -10.74. In the year 2009, what is the difference between the Total Labor Force (in %) of Middle East & North Africa (all income levels) and Total Labor Force (in %) of Sudan?
Provide a short and direct response. -11.54. In the year 2009, what is the difference between the Total Labor Force (in %) in Sub-Saharan Africa (all income levels) and Total Labor Force (in %) in Romania?
Give a very brief answer. 24.99. In the year 2009, what is the difference between the Total Labor Force (in %) of Sub-Saharan Africa (all income levels) and Total Labor Force (in %) of Sudan?
Provide a short and direct response. 24.19. In the year 2009, what is the difference between the Total Labor Force (in %) of Romania and Total Labor Force (in %) of Sudan?
Make the answer very short. -0.8. In the year 2010, what is the difference between the Total Labor Force (in %) in Middle East & North Africa (all income levels) and Total Labor Force (in %) in Sub-Saharan Africa (all income levels)?
Make the answer very short. -35.55. In the year 2010, what is the difference between the Total Labor Force (in %) in Middle East & North Africa (all income levels) and Total Labor Force (in %) in Romania?
Make the answer very short. -10.72. In the year 2010, what is the difference between the Total Labor Force (in %) in Middle East & North Africa (all income levels) and Total Labor Force (in %) in Sudan?
Provide a succinct answer. -11.52. In the year 2010, what is the difference between the Total Labor Force (in %) of Sub-Saharan Africa (all income levels) and Total Labor Force (in %) of Romania?
Your answer should be very brief. 24.83. In the year 2010, what is the difference between the Total Labor Force (in %) of Sub-Saharan Africa (all income levels) and Total Labor Force (in %) of Sudan?
Your response must be concise. 24.03. In the year 2010, what is the difference between the Total Labor Force (in %) of Romania and Total Labor Force (in %) of Sudan?
Your answer should be compact. -0.8. What is the ratio of the Total Labor Force (in %) in Sub-Saharan Africa (all income levels) in 2004 to that in 2005?
Offer a very short reply. 1. What is the ratio of the Total Labor Force (in %) of Romania in 2004 to that in 2005?
Ensure brevity in your answer.  1.19. What is the ratio of the Total Labor Force (in %) of Middle East & North Africa (all income levels) in 2004 to that in 2006?
Offer a very short reply. 1.05. What is the ratio of the Total Labor Force (in %) of Sub-Saharan Africa (all income levels) in 2004 to that in 2006?
Make the answer very short. 1. What is the ratio of the Total Labor Force (in %) of Romania in 2004 to that in 2006?
Offer a terse response. 1.21. What is the ratio of the Total Labor Force (in %) in Sudan in 2004 to that in 2006?
Your response must be concise. 1. What is the ratio of the Total Labor Force (in %) of Middle East & North Africa (all income levels) in 2004 to that in 2007?
Your response must be concise. 1.1. What is the ratio of the Total Labor Force (in %) of Sub-Saharan Africa (all income levels) in 2004 to that in 2007?
Offer a terse response. 1. What is the ratio of the Total Labor Force (in %) in Romania in 2004 to that in 2007?
Keep it short and to the point. 1.25. What is the ratio of the Total Labor Force (in %) in Sudan in 2004 to that in 2007?
Give a very brief answer. 1. What is the ratio of the Total Labor Force (in %) in Middle East & North Africa (all income levels) in 2004 to that in 2008?
Offer a very short reply. 1.13. What is the ratio of the Total Labor Force (in %) of Sub-Saharan Africa (all income levels) in 2004 to that in 2008?
Ensure brevity in your answer.  1. What is the ratio of the Total Labor Force (in %) of Romania in 2004 to that in 2008?
Ensure brevity in your answer.  1.26. What is the ratio of the Total Labor Force (in %) in Middle East & North Africa (all income levels) in 2004 to that in 2009?
Keep it short and to the point. 1.15. What is the ratio of the Total Labor Force (in %) of Romania in 2004 to that in 2009?
Your response must be concise. 1.2. What is the ratio of the Total Labor Force (in %) of Sudan in 2004 to that in 2009?
Offer a terse response. 1. What is the ratio of the Total Labor Force (in %) in Middle East & North Africa (all income levels) in 2004 to that in 2010?
Your response must be concise. 1.14. What is the ratio of the Total Labor Force (in %) of Sub-Saharan Africa (all income levels) in 2004 to that in 2010?
Your answer should be very brief. 1.01. What is the ratio of the Total Labor Force (in %) of Romania in 2004 to that in 2010?
Provide a short and direct response. 1.2. What is the ratio of the Total Labor Force (in %) of Sudan in 2004 to that in 2010?
Ensure brevity in your answer.  1. What is the ratio of the Total Labor Force (in %) of Middle East & North Africa (all income levels) in 2005 to that in 2006?
Your answer should be compact. 1.05. What is the ratio of the Total Labor Force (in %) of Romania in 2005 to that in 2006?
Your response must be concise. 1.02. What is the ratio of the Total Labor Force (in %) in Sudan in 2005 to that in 2006?
Offer a very short reply. 1. What is the ratio of the Total Labor Force (in %) of Middle East & North Africa (all income levels) in 2005 to that in 2007?
Your answer should be very brief. 1.1. What is the ratio of the Total Labor Force (in %) in Sub-Saharan Africa (all income levels) in 2005 to that in 2007?
Ensure brevity in your answer.  1. What is the ratio of the Total Labor Force (in %) of Romania in 2005 to that in 2007?
Your response must be concise. 1.05. What is the ratio of the Total Labor Force (in %) in Sudan in 2005 to that in 2007?
Offer a terse response. 1. What is the ratio of the Total Labor Force (in %) of Middle East & North Africa (all income levels) in 2005 to that in 2008?
Provide a succinct answer. 1.13. What is the ratio of the Total Labor Force (in %) in Sub-Saharan Africa (all income levels) in 2005 to that in 2008?
Provide a succinct answer. 1. What is the ratio of the Total Labor Force (in %) of Romania in 2005 to that in 2008?
Your response must be concise. 1.06. What is the ratio of the Total Labor Force (in %) in Sudan in 2005 to that in 2008?
Offer a very short reply. 1. What is the ratio of the Total Labor Force (in %) of Middle East & North Africa (all income levels) in 2005 to that in 2009?
Offer a terse response. 1.15. What is the ratio of the Total Labor Force (in %) of Sub-Saharan Africa (all income levels) in 2005 to that in 2009?
Provide a succinct answer. 1. What is the ratio of the Total Labor Force (in %) in Romania in 2005 to that in 2009?
Your response must be concise. 1.01. What is the ratio of the Total Labor Force (in %) in Sudan in 2005 to that in 2009?
Ensure brevity in your answer.  1. What is the ratio of the Total Labor Force (in %) of Middle East & North Africa (all income levels) in 2005 to that in 2010?
Provide a short and direct response. 1.14. What is the ratio of the Total Labor Force (in %) in Romania in 2005 to that in 2010?
Provide a succinct answer. 1.01. What is the ratio of the Total Labor Force (in %) in Middle East & North Africa (all income levels) in 2006 to that in 2007?
Give a very brief answer. 1.05. What is the ratio of the Total Labor Force (in %) in Sub-Saharan Africa (all income levels) in 2006 to that in 2007?
Your answer should be compact. 1. What is the ratio of the Total Labor Force (in %) of Romania in 2006 to that in 2007?
Keep it short and to the point. 1.04. What is the ratio of the Total Labor Force (in %) of Sudan in 2006 to that in 2007?
Keep it short and to the point. 1. What is the ratio of the Total Labor Force (in %) in Middle East & North Africa (all income levels) in 2006 to that in 2008?
Your response must be concise. 1.08. What is the ratio of the Total Labor Force (in %) of Sub-Saharan Africa (all income levels) in 2006 to that in 2008?
Make the answer very short. 1. What is the ratio of the Total Labor Force (in %) in Romania in 2006 to that in 2008?
Ensure brevity in your answer.  1.04. What is the ratio of the Total Labor Force (in %) of Middle East & North Africa (all income levels) in 2006 to that in 2009?
Provide a succinct answer. 1.09. What is the ratio of the Total Labor Force (in %) of Sub-Saharan Africa (all income levels) in 2006 to that in 2009?
Your response must be concise. 1. What is the ratio of the Total Labor Force (in %) of Sudan in 2006 to that in 2009?
Offer a very short reply. 1. What is the ratio of the Total Labor Force (in %) of Middle East & North Africa (all income levels) in 2006 to that in 2010?
Your response must be concise. 1.09. What is the ratio of the Total Labor Force (in %) of Sub-Saharan Africa (all income levels) in 2006 to that in 2010?
Your answer should be compact. 1.01. What is the ratio of the Total Labor Force (in %) in Romania in 2006 to that in 2010?
Give a very brief answer. 0.99. What is the ratio of the Total Labor Force (in %) in Middle East & North Africa (all income levels) in 2007 to that in 2008?
Offer a very short reply. 1.03. What is the ratio of the Total Labor Force (in %) of Sub-Saharan Africa (all income levels) in 2007 to that in 2008?
Ensure brevity in your answer.  1. What is the ratio of the Total Labor Force (in %) in Romania in 2007 to that in 2008?
Offer a very short reply. 1. What is the ratio of the Total Labor Force (in %) of Middle East & North Africa (all income levels) in 2007 to that in 2009?
Ensure brevity in your answer.  1.05. What is the ratio of the Total Labor Force (in %) in Romania in 2007 to that in 2009?
Make the answer very short. 0.96. What is the ratio of the Total Labor Force (in %) in Middle East & North Africa (all income levels) in 2007 to that in 2010?
Make the answer very short. 1.04. What is the ratio of the Total Labor Force (in %) of Sub-Saharan Africa (all income levels) in 2007 to that in 2010?
Offer a terse response. 1. What is the ratio of the Total Labor Force (in %) of Romania in 2007 to that in 2010?
Ensure brevity in your answer.  0.96. What is the ratio of the Total Labor Force (in %) in Sudan in 2007 to that in 2010?
Your response must be concise. 1. What is the ratio of the Total Labor Force (in %) of Middle East & North Africa (all income levels) in 2008 to that in 2009?
Provide a succinct answer. 1.01. What is the ratio of the Total Labor Force (in %) of Sub-Saharan Africa (all income levels) in 2008 to that in 2009?
Keep it short and to the point. 1. What is the ratio of the Total Labor Force (in %) in Romania in 2008 to that in 2009?
Make the answer very short. 0.96. What is the ratio of the Total Labor Force (in %) of Sudan in 2008 to that in 2009?
Provide a succinct answer. 1. What is the ratio of the Total Labor Force (in %) of Romania in 2008 to that in 2010?
Give a very brief answer. 0.95. What is the ratio of the Total Labor Force (in %) in Sudan in 2008 to that in 2010?
Keep it short and to the point. 1. What is the ratio of the Total Labor Force (in %) of Sub-Saharan Africa (all income levels) in 2009 to that in 2010?
Provide a short and direct response. 1. What is the ratio of the Total Labor Force (in %) in Romania in 2009 to that in 2010?
Give a very brief answer. 1. What is the difference between the highest and the second highest Total Labor Force (in %) in Middle East & North Africa (all income levels)?
Provide a succinct answer. 0.01. What is the difference between the highest and the second highest Total Labor Force (in %) of Sub-Saharan Africa (all income levels)?
Your answer should be compact. 0.02. What is the difference between the highest and the second highest Total Labor Force (in %) of Romania?
Your answer should be very brief. 5. What is the difference between the highest and the second highest Total Labor Force (in %) in Sudan?
Your answer should be very brief. 0.1. What is the difference between the highest and the lowest Total Labor Force (in %) of Middle East & North Africa (all income levels)?
Your response must be concise. 2.26. What is the difference between the highest and the lowest Total Labor Force (in %) of Sub-Saharan Africa (all income levels)?
Keep it short and to the point. 0.28. 